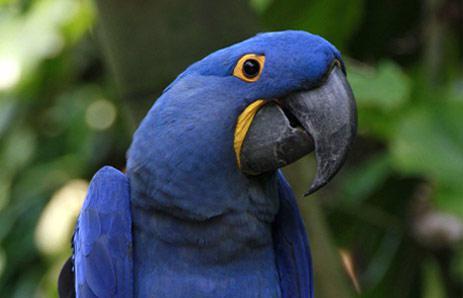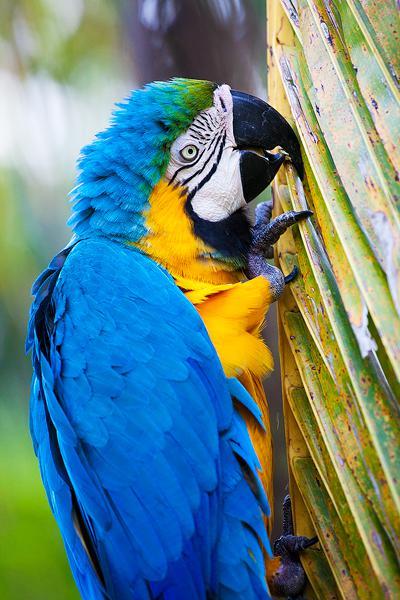The first image is the image on the left, the second image is the image on the right. Examine the images to the left and right. Is the description "The bird in the image on the right has its wings spread." accurate? Answer yes or no. No. The first image is the image on the left, the second image is the image on the right. Assess this claim about the two images: "One image contains a bird with spread wings, and the other image shows a perching bird with a red head.". Correct or not? Answer yes or no. No. 